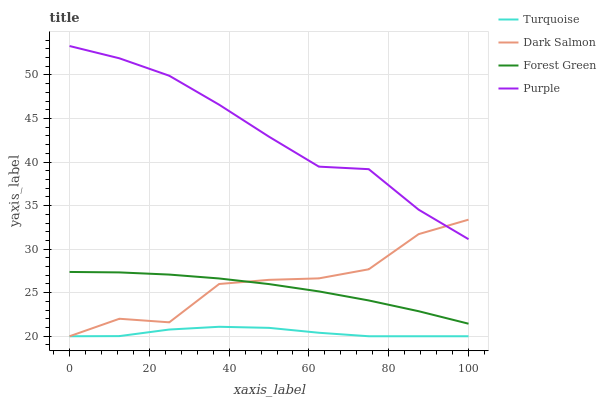Does Purple have the minimum area under the curve?
Answer yes or no. No. Does Turquoise have the maximum area under the curve?
Answer yes or no. No. Is Purple the smoothest?
Answer yes or no. No. Is Purple the roughest?
Answer yes or no. No. Does Purple have the lowest value?
Answer yes or no. No. Does Turquoise have the highest value?
Answer yes or no. No. Is Turquoise less than Purple?
Answer yes or no. Yes. Is Purple greater than Forest Green?
Answer yes or no. Yes. Does Turquoise intersect Purple?
Answer yes or no. No. 